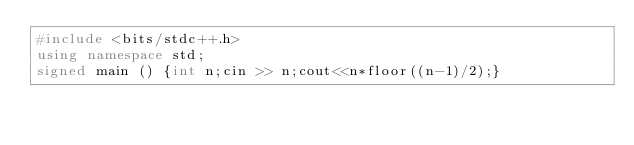Convert code to text. <code><loc_0><loc_0><loc_500><loc_500><_C++_>#include <bits/stdc++.h>
using namespace std;
signed main () {int n;cin >> n;cout<<n*floor((n-1)/2);}</code> 